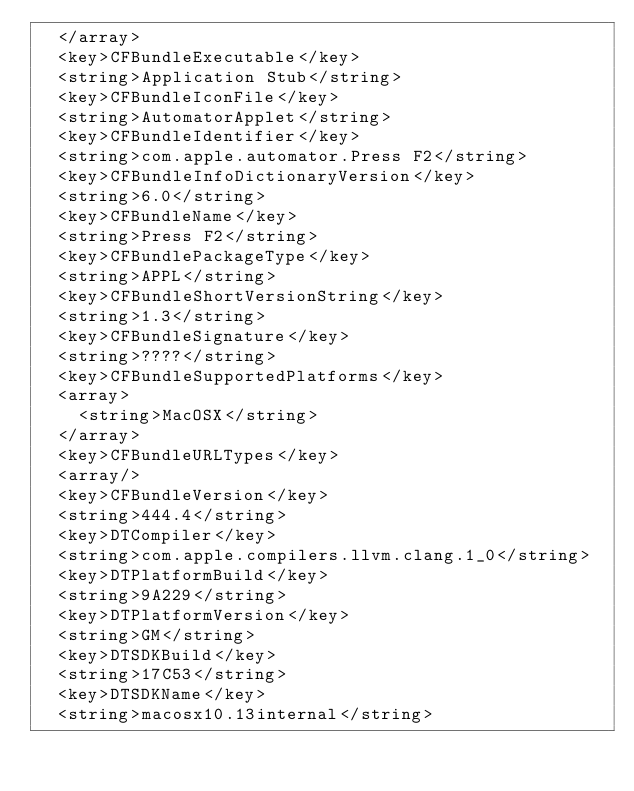Convert code to text. <code><loc_0><loc_0><loc_500><loc_500><_XML_>	</array>
	<key>CFBundleExecutable</key>
	<string>Application Stub</string>
	<key>CFBundleIconFile</key>
	<string>AutomatorApplet</string>
	<key>CFBundleIdentifier</key>
	<string>com.apple.automator.Press F2</string>
	<key>CFBundleInfoDictionaryVersion</key>
	<string>6.0</string>
	<key>CFBundleName</key>
	<string>Press F2</string>
	<key>CFBundlePackageType</key>
	<string>APPL</string>
	<key>CFBundleShortVersionString</key>
	<string>1.3</string>
	<key>CFBundleSignature</key>
	<string>????</string>
	<key>CFBundleSupportedPlatforms</key>
	<array>
		<string>MacOSX</string>
	</array>
	<key>CFBundleURLTypes</key>
	<array/>
	<key>CFBundleVersion</key>
	<string>444.4</string>
	<key>DTCompiler</key>
	<string>com.apple.compilers.llvm.clang.1_0</string>
	<key>DTPlatformBuild</key>
	<string>9A229</string>
	<key>DTPlatformVersion</key>
	<string>GM</string>
	<key>DTSDKBuild</key>
	<string>17C53</string>
	<key>DTSDKName</key>
	<string>macosx10.13internal</string></code> 